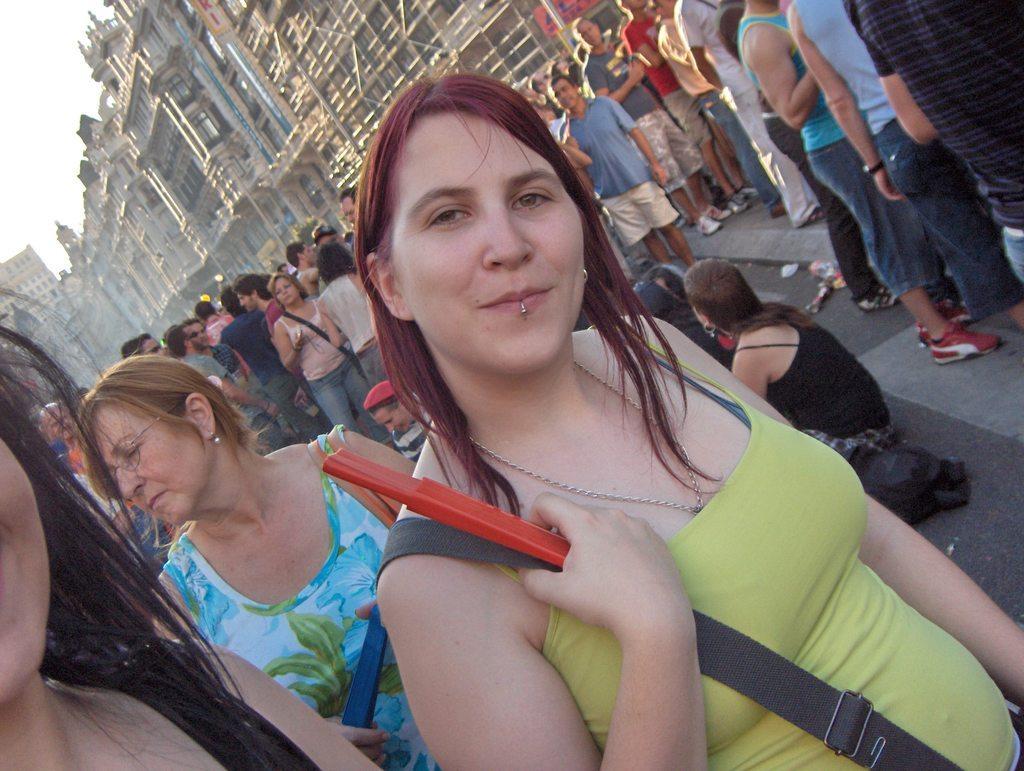Describe this image in one or two sentences. In the image there are many people in the foreground and behind them there are buildings. 